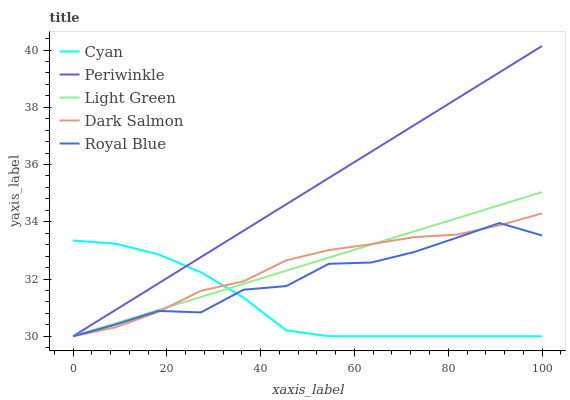Does Dark Salmon have the minimum area under the curve?
Answer yes or no. No. Does Dark Salmon have the maximum area under the curve?
Answer yes or no. No. Is Periwinkle the smoothest?
Answer yes or no. No. Is Periwinkle the roughest?
Answer yes or no. No. Does Dark Salmon have the highest value?
Answer yes or no. No. 